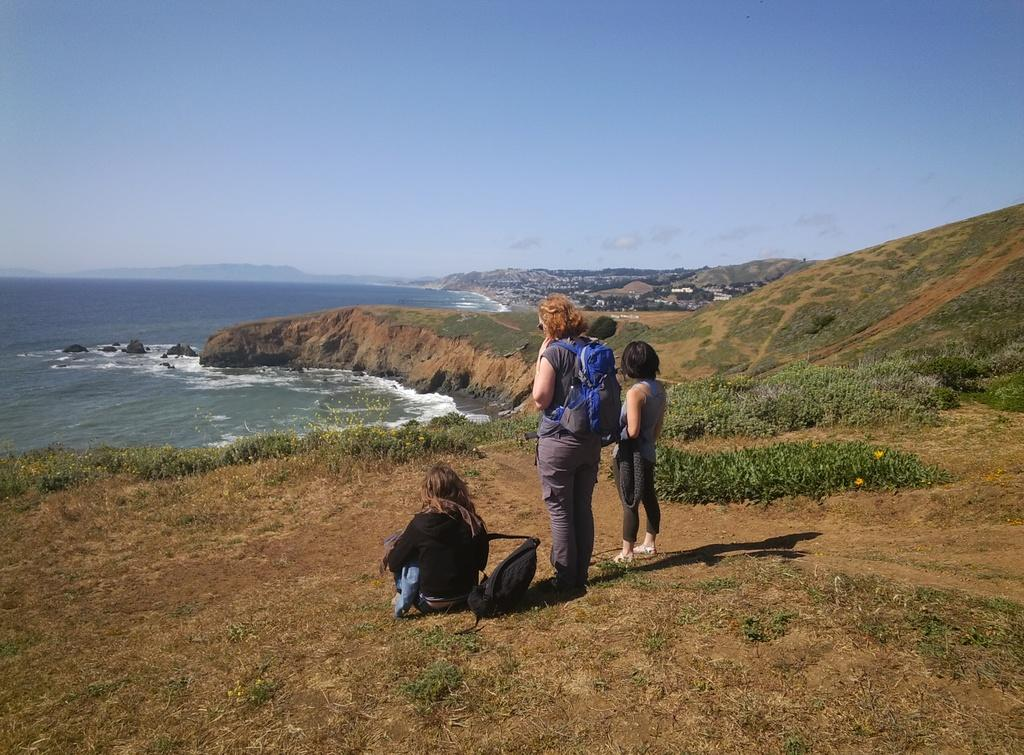What type of water body is shown in the image? The image depicts a freshwater river. How many people are in the image? There are two persons standing in the image. What are the people wearing that might be used for carrying items? Both persons are wearing bags. What is one person doing in the image? One person is in a squat position and holding a bag. What else can be seen in the image besides the people and the river? There are plants visible in the image. What color is the crayon being used by the person in the image? There is no crayon present in the image. What type of sweater is the lawyer wearing in the image? There is no lawyer or sweater present in the image. 